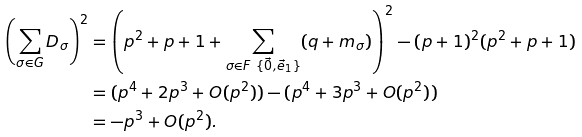<formula> <loc_0><loc_0><loc_500><loc_500>\left ( \sum _ { \sigma \in G } D _ { \sigma } \right ) ^ { 2 } & = \left ( p ^ { 2 } + p + 1 + \sum _ { \sigma \in F \ \{ \vec { 0 } , \vec { e } _ { 1 } \} } ( q + m _ { \sigma } ) \right ) ^ { 2 } - ( p + 1 ) ^ { 2 } ( p ^ { 2 } + p + 1 ) \\ & = ( p ^ { 4 } + 2 p ^ { 3 } + O ( p ^ { 2 } ) ) - ( p ^ { 4 } + 3 p ^ { 3 } + O ( p ^ { 2 } ) ) \\ & = - p ^ { 3 } + O ( p ^ { 2 } ) .</formula> 